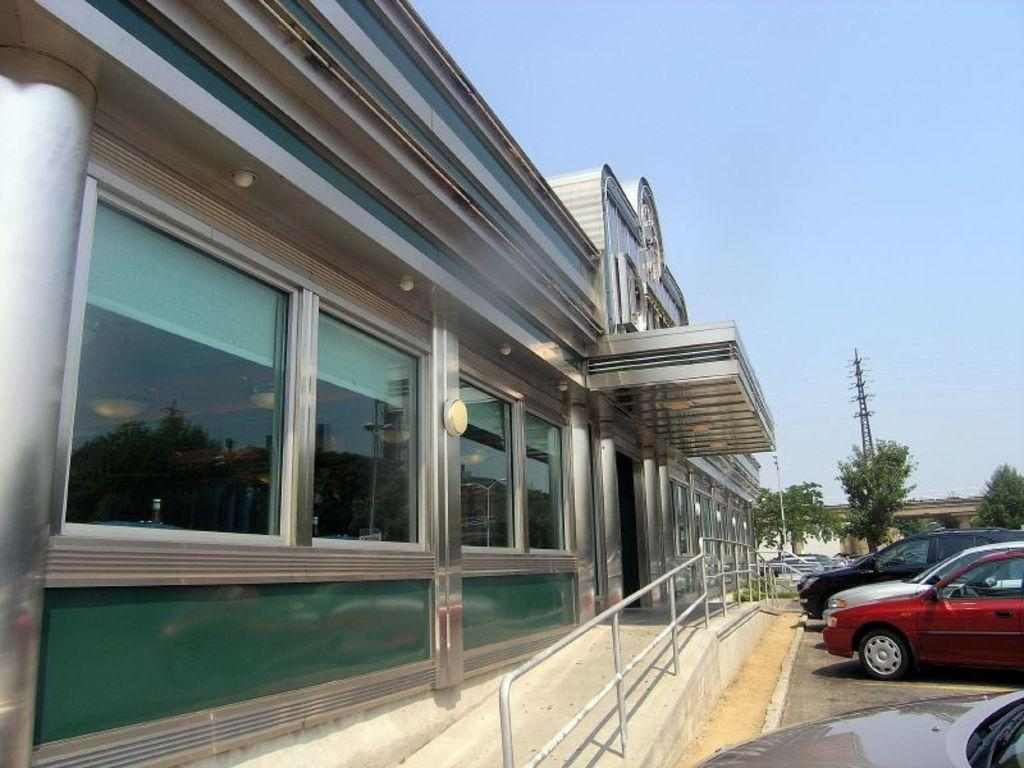What type of structure is present in the image? There is a building in the image. What else can be seen in the image besides the building? There are vehicles and trees in the image. Can you describe the tall structure in the image? There is a tower in the image. What is visible in the background of the image? The sky is visible in the background of the image. How many pizzas are being delivered by the passenger in the image? There is no passenger or pizzas present in the image. What is the best way to reach the top of the tower in the image? The image does not provide information on how to reach the top of the tower, nor does it show a way to access it. 